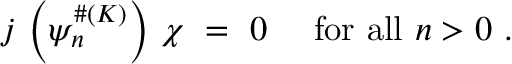Convert formula to latex. <formula><loc_0><loc_0><loc_500><loc_500>j \, \left ( \psi _ { n } ^ { \# ( K ) } \right ) \, \chi \ = \ 0 \ \quad f o r \ a l l \ n > 0 \ .</formula> 